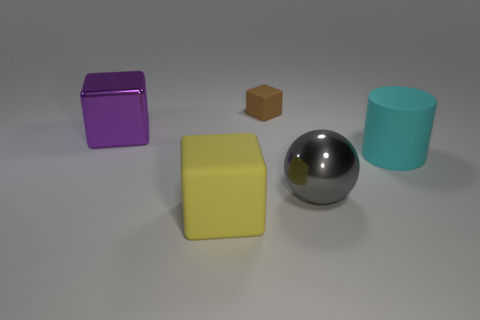Is the number of cyan cylinders that are behind the matte cylinder the same as the number of large cyan matte things that are behind the tiny brown block?
Your answer should be compact. Yes. There is a large rubber thing left of the large metallic thing that is in front of the big purple cube; are there any large gray balls to the right of it?
Your answer should be compact. Yes. Is the size of the cyan rubber thing the same as the yellow rubber thing?
Give a very brief answer. Yes. What color is the rubber cube on the left side of the small matte object behind the large object that is in front of the big metallic sphere?
Offer a terse response. Yellow. How many large cylinders have the same color as the small matte thing?
Make the answer very short. 0. What number of tiny objects are either cyan balls or purple shiny things?
Your answer should be compact. 0. Is there a big yellow matte thing that has the same shape as the purple shiny thing?
Give a very brief answer. Yes. Does the big yellow rubber thing have the same shape as the big cyan matte thing?
Ensure brevity in your answer.  No. What is the color of the large thing behind the object that is on the right side of the sphere?
Your answer should be compact. Purple. What is the color of the matte cube that is the same size as the sphere?
Make the answer very short. Yellow. 